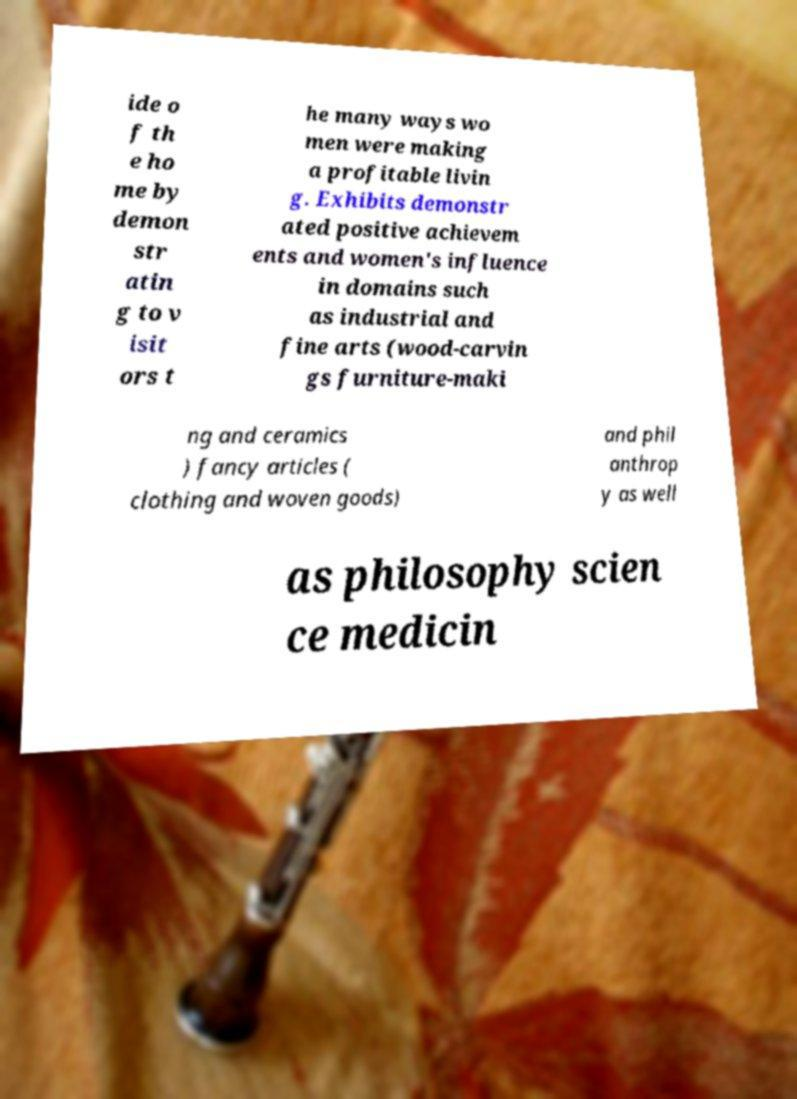Can you read and provide the text displayed in the image?This photo seems to have some interesting text. Can you extract and type it out for me? ide o f th e ho me by demon str atin g to v isit ors t he many ways wo men were making a profitable livin g. Exhibits demonstr ated positive achievem ents and women's influence in domains such as industrial and fine arts (wood-carvin gs furniture-maki ng and ceramics ) fancy articles ( clothing and woven goods) and phil anthrop y as well as philosophy scien ce medicin 